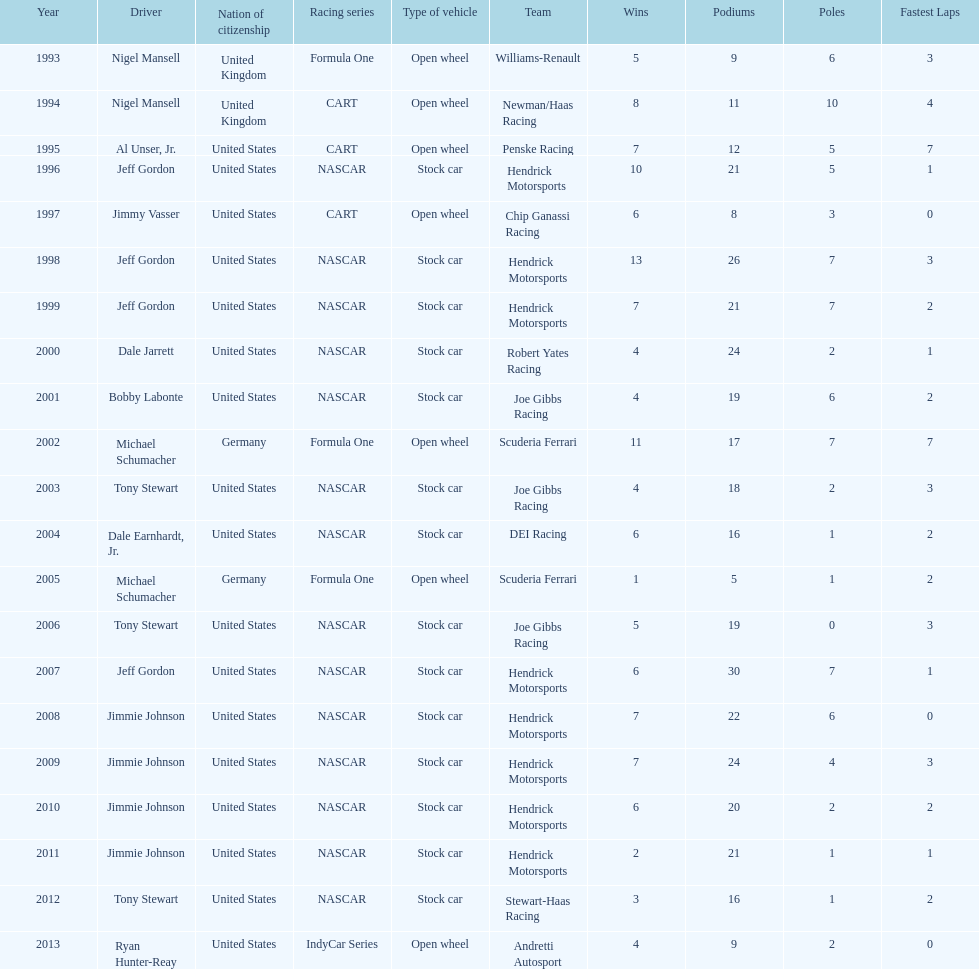Would you be able to parse every entry in this table? {'header': ['Year', 'Driver', 'Nation of citizenship', 'Racing series', 'Type of vehicle', 'Team', 'Wins', 'Podiums', 'Poles', 'Fastest Laps'], 'rows': [['1993', 'Nigel Mansell', 'United Kingdom', 'Formula One', 'Open wheel', 'Williams-Renault', '5', '9', '6', '3'], ['1994', 'Nigel Mansell', 'United Kingdom', 'CART', 'Open wheel', 'Newman/Haas Racing', '8', '11', '10', '4'], ['1995', 'Al Unser, Jr.', 'United States', 'CART', 'Open wheel', 'Penske Racing', '7', '12', '5', '7'], ['1996', 'Jeff Gordon', 'United States', 'NASCAR', 'Stock car', 'Hendrick Motorsports ', '10', '21', '5', '1'], ['1997', 'Jimmy Vasser', 'United States', 'CART', 'Open wheel', 'Chip Ganassi Racing', '6', '8', '3', '0'], ['1998', 'Jeff Gordon', 'United States', 'NASCAR', 'Stock car', 'Hendrick Motorsports', '13', '26', '7', '3'], ['1999', 'Jeff Gordon', 'United States', 'NASCAR', 'Stock car', 'Hendrick Motorsports', '7', '21', '7', '2'], ['2000', 'Dale Jarrett', 'United States', 'NASCAR', 'Stock car', 'Robert Yates Racing', '4', '24', '2', '1'], ['2001', 'Bobby Labonte', 'United States', 'NASCAR', 'Stock car', 'Joe Gibbs Racing', '4', '19', '6', '2'], ['2002', 'Michael Schumacher', 'Germany', 'Formula One', 'Open wheel', 'Scuderia Ferrari', '11', '17', '7', '7'], ['2003', 'Tony Stewart', 'United States', 'NASCAR', 'Stock car', 'Joe Gibbs Racing', '4', '18', '2', '3'], ['2004', 'Dale Earnhardt, Jr.', 'United States', 'NASCAR', 'Stock car', 'DEI Racing', '6', '16', '1', '2'], ['2005', 'Michael Schumacher', 'Germany', 'Formula One', 'Open wheel', 'Scuderia Ferrari', '1', '5', '1', '2'], ['2006', 'Tony Stewart', 'United States', 'NASCAR', 'Stock car', 'Joe Gibbs Racing', '5', '19', '0', '3'], ['2007', 'Jeff Gordon', 'United States', 'NASCAR', 'Stock car', 'Hendrick Motorsports', '6', '30', '7', '1'], ['2008', 'Jimmie Johnson', 'United States', 'NASCAR', 'Stock car', 'Hendrick Motorsports', '7', '22', '6', '0'], ['2009', 'Jimmie Johnson', 'United States', 'NASCAR', 'Stock car', 'Hendrick Motorsports', '7', '24', '4', '3'], ['2010', 'Jimmie Johnson', 'United States', 'NASCAR', 'Stock car', 'Hendrick Motorsports', '6', '20', '2', '2'], ['2011', 'Jimmie Johnson', 'United States', 'NASCAR', 'Stock car', 'Hendrick Motorsports', '2', '21', '1', '1'], ['2012', 'Tony Stewart', 'United States', 'NASCAR', 'Stock car', 'Stewart-Haas Racing', '3', '16', '1', '2'], ['2013', 'Ryan Hunter-Reay', 'United States', 'IndyCar Series', 'Open wheel', 'Andretti Autosport', '4', '9', '2', '0']]} How many total row entries are there? 21. 